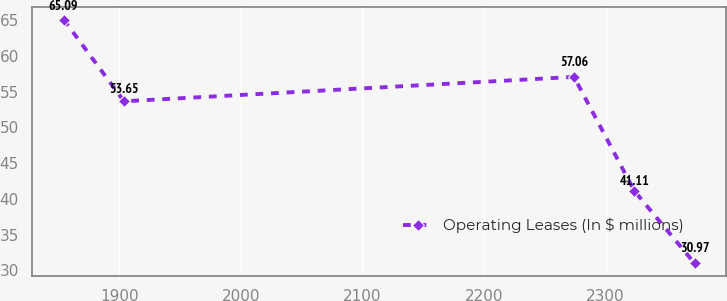Convert chart to OTSL. <chart><loc_0><loc_0><loc_500><loc_500><line_chart><ecel><fcel>Operating Leases (In $ millions)<nl><fcel>1854.17<fcel>65.09<nl><fcel>1903.8<fcel>53.65<nl><fcel>2274.09<fcel>57.06<nl><fcel>2323.72<fcel>41.11<nl><fcel>2373.35<fcel>30.97<nl></chart> 